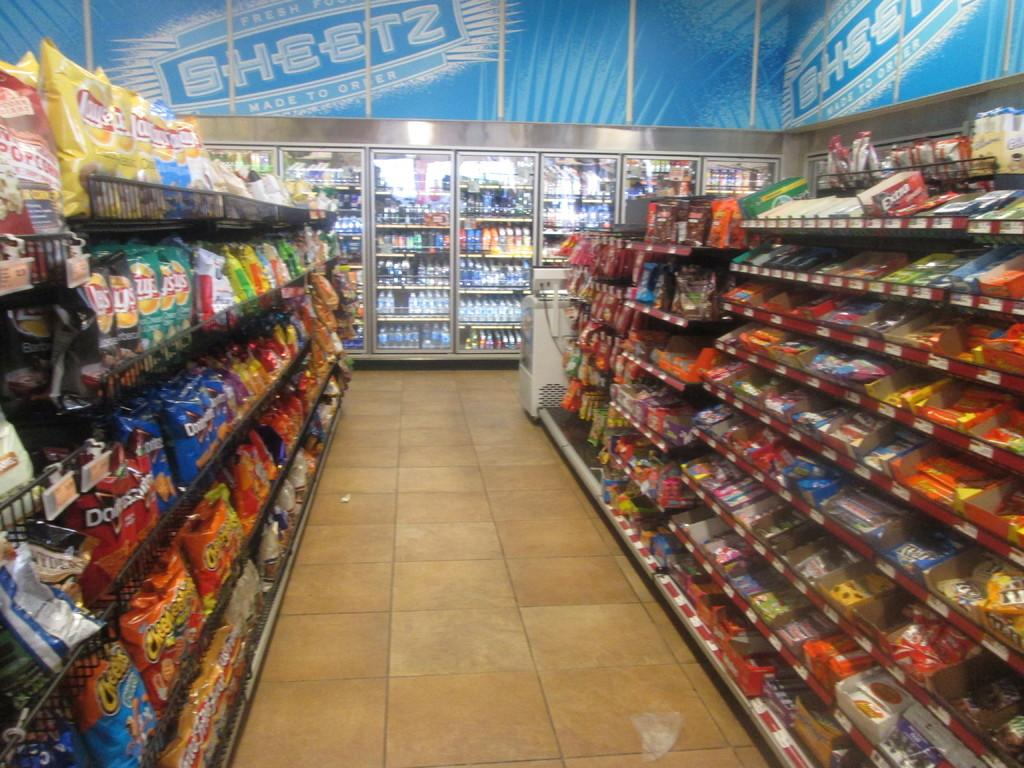<image>
Provide a brief description of the given image. Sheets banner on top of fridge and bags of Doritos and Cheetos chips on shelf. 